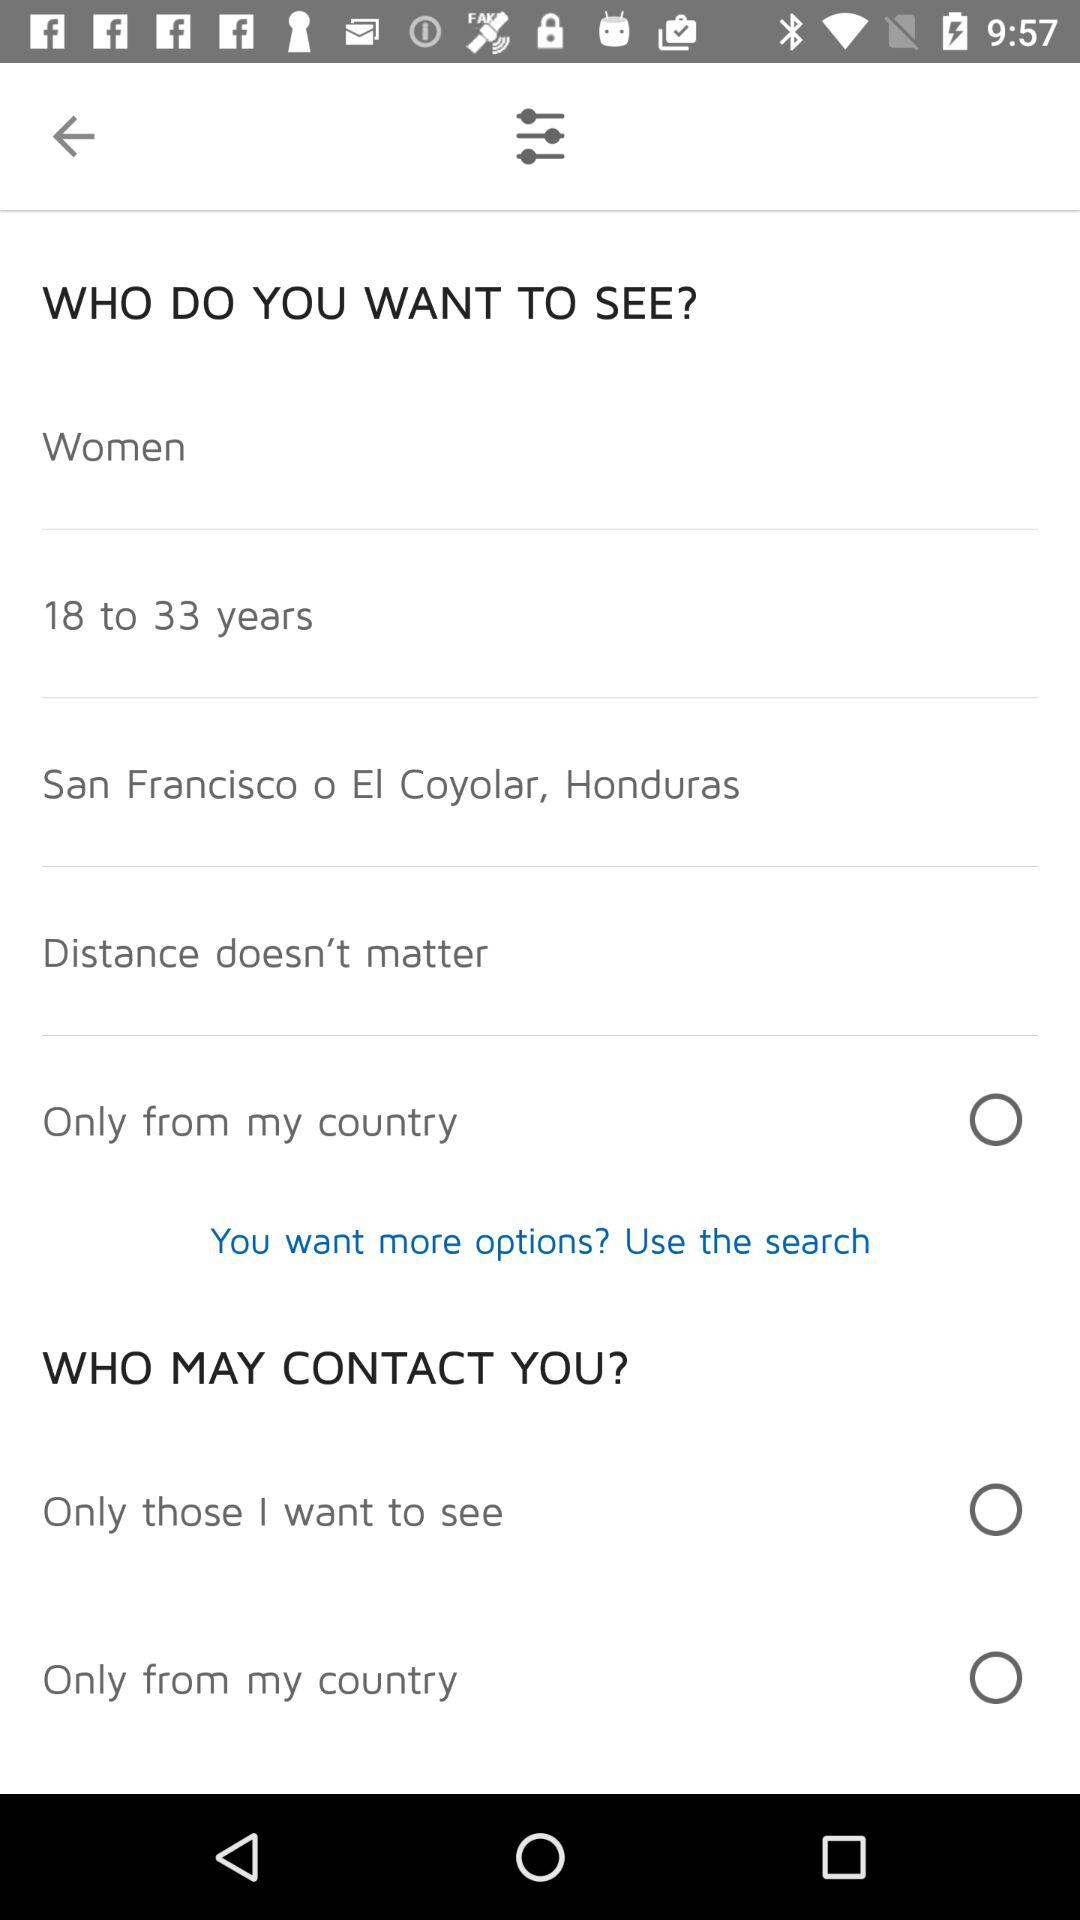How many options for who may contact you are there?
Answer the question using a single word or phrase. 2 